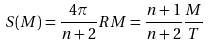<formula> <loc_0><loc_0><loc_500><loc_500>S ( M ) = \frac { 4 \pi } { n + 2 } R M = \frac { n + 1 } { n + 2 } \frac { M } { T }</formula> 